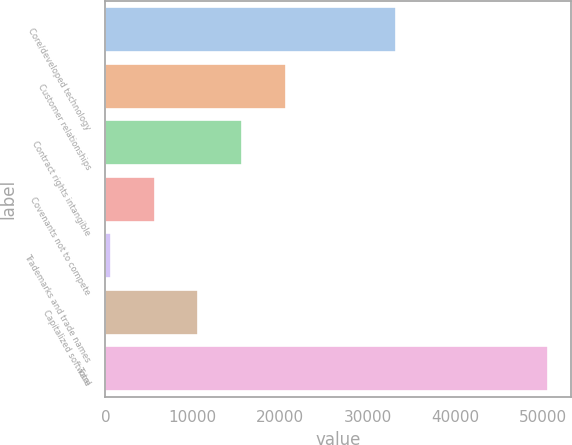Convert chart. <chart><loc_0><loc_0><loc_500><loc_500><bar_chart><fcel>Core/developed technology<fcel>Customer relationships<fcel>Contract rights intangible<fcel>Covenants not to compete<fcel>Trademarks and trade names<fcel>Capitalized software<fcel>Total<nl><fcel>33232<fcel>20637.6<fcel>15635.7<fcel>5631.9<fcel>630<fcel>10633.8<fcel>50649<nl></chart> 